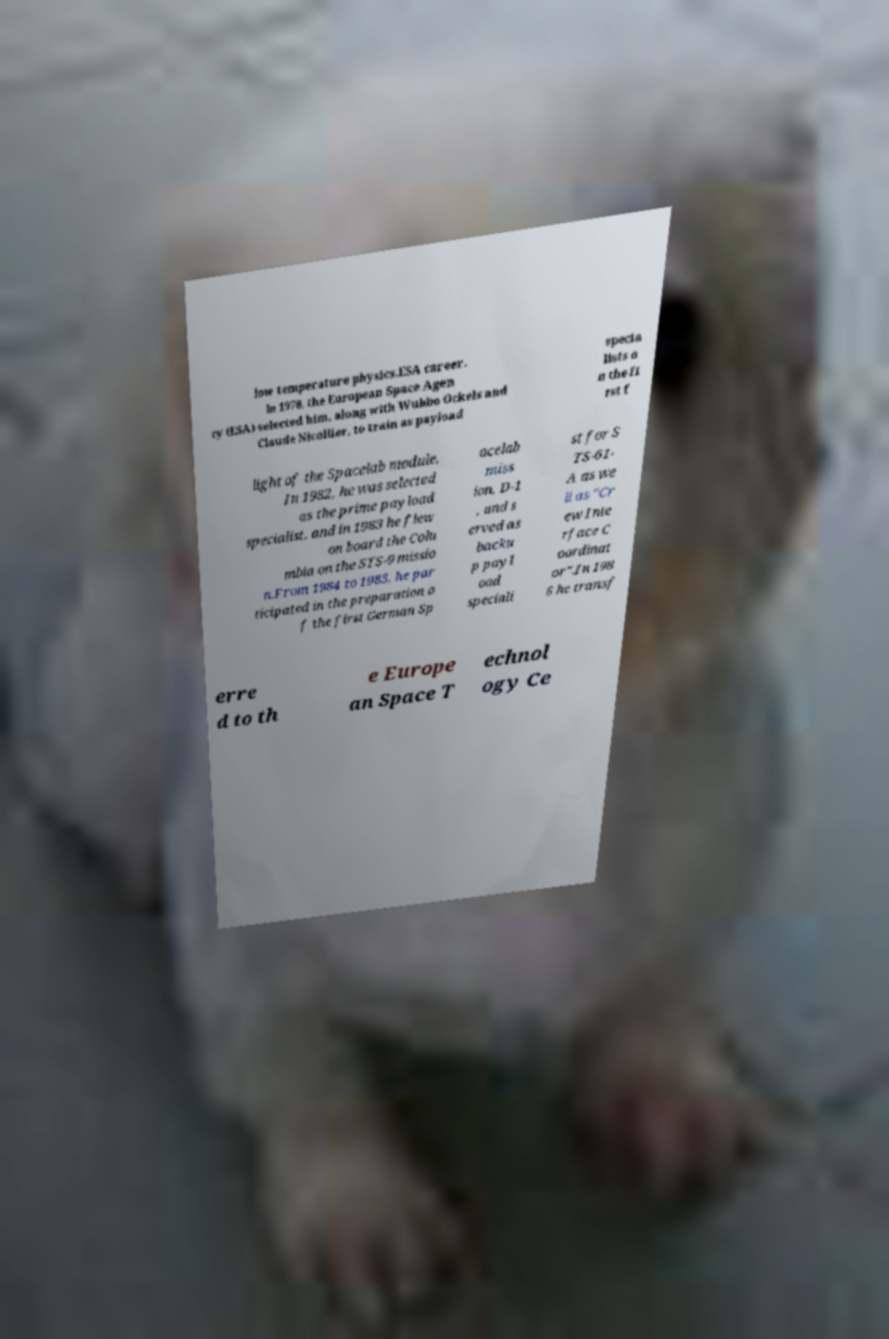Could you extract and type out the text from this image? low temperature physics.ESA career. In 1978, the European Space Agen cy (ESA) selected him, along with Wubbo Ockels and Claude Nicollier, to train as payload specia lists o n the fi rst f light of the Spacelab module. In 1982, he was selected as the prime payload specialist, and in 1983 he flew on board the Colu mbia on the STS-9 missio n.From 1984 to 1985, he par ticipated in the preparation o f the first German Sp acelab miss ion, D-1 , and s erved as backu p payl oad speciali st for S TS-61- A as we ll as "Cr ew Inte rface C oordinat or".In 198 6 he transf erre d to th e Europe an Space T echnol ogy Ce 